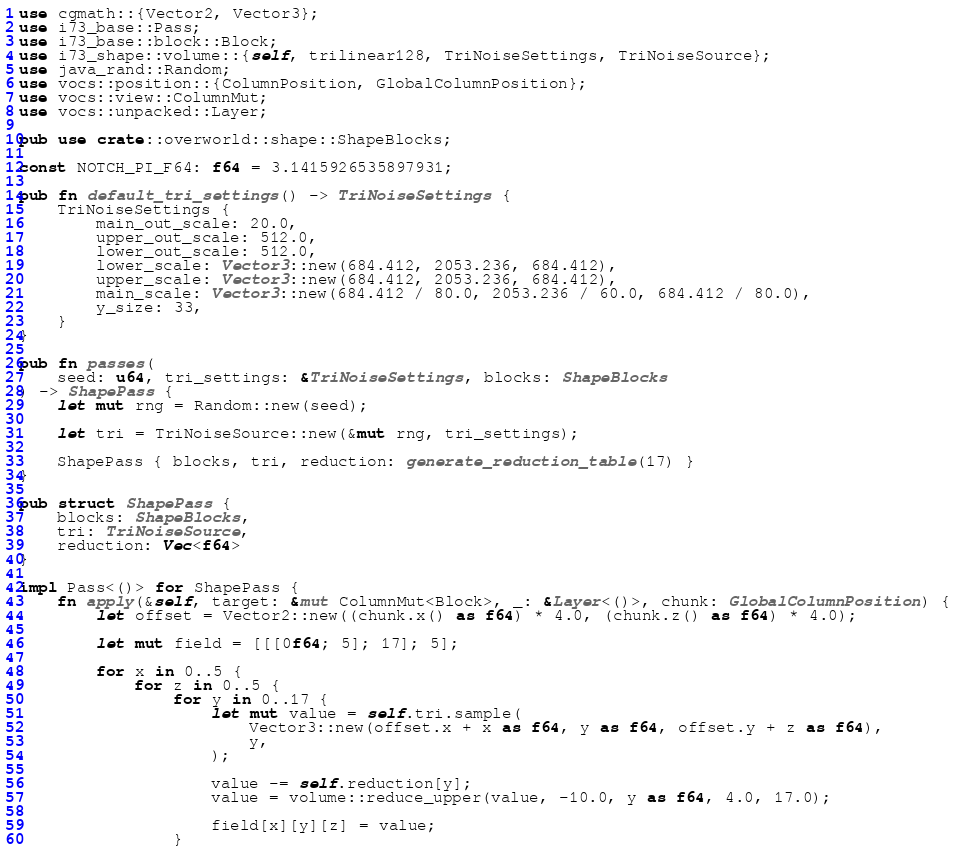Convert code to text. <code><loc_0><loc_0><loc_500><loc_500><_Rust_>use cgmath::{Vector2, Vector3};
use i73_base::Pass;
use i73_base::block::Block;
use i73_shape::volume::{self, trilinear128, TriNoiseSettings, TriNoiseSource};
use java_rand::Random;
use vocs::position::{ColumnPosition, GlobalColumnPosition};
use vocs::view::ColumnMut;
use vocs::unpacked::Layer;

pub use crate::overworld::shape::ShapeBlocks;

const NOTCH_PI_F64: f64 = 3.1415926535897931;

pub fn default_tri_settings() -> TriNoiseSettings {
	TriNoiseSettings {
		main_out_scale: 20.0,
		upper_out_scale: 512.0,
		lower_out_scale: 512.0,
		lower_scale: Vector3::new(684.412, 2053.236, 684.412),
		upper_scale: Vector3::new(684.412, 2053.236, 684.412),
		main_scale: Vector3::new(684.412 / 80.0, 2053.236 / 60.0, 684.412 / 80.0),
		y_size: 33,
	}
}

pub fn passes(
	seed: u64, tri_settings: &TriNoiseSettings, blocks: ShapeBlocks
) -> ShapePass {
	let mut rng = Random::new(seed);

	let tri = TriNoiseSource::new(&mut rng, tri_settings);

	ShapePass { blocks, tri, reduction: generate_reduction_table(17) }
}

pub struct ShapePass {
	blocks: ShapeBlocks,
	tri: TriNoiseSource,
	reduction: Vec<f64>
}

impl Pass<()> for ShapePass {
	fn apply(&self, target: &mut ColumnMut<Block>, _: &Layer<()>, chunk: GlobalColumnPosition) {
		let offset = Vector2::new((chunk.x() as f64) * 4.0, (chunk.z() as f64) * 4.0);

		let mut field = [[[0f64; 5]; 17]; 5];

		for x in 0..5 {
			for z in 0..5 {
				for y in 0..17 {
					let mut value = self.tri.sample(
						Vector3::new(offset.x + x as f64, y as f64, offset.y + z as f64),
						y,
					);

					value -= self.reduction[y];
					value = volume::reduce_upper(value, -10.0, y as f64, 4.0, 17.0);

					field[x][y][z] = value;
				}</code> 